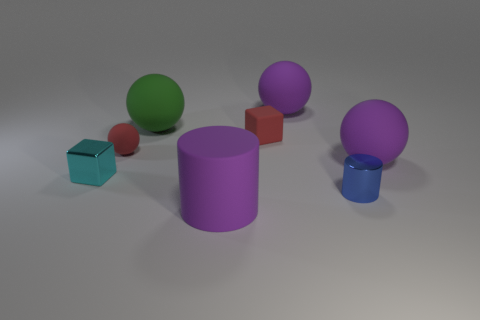There is a tiny block that is to the right of the rubber cylinder; is its color the same as the tiny rubber ball?
Your response must be concise. Yes. How many other things are there of the same color as the big cylinder?
Your answer should be very brief. 2. What number of objects are either objects or tiny red matte blocks?
Ensure brevity in your answer.  8. How many things are green balls or tiny red things that are left of the red matte block?
Your response must be concise. 2. Is the cyan cube made of the same material as the red sphere?
Provide a succinct answer. No. What number of other objects are there of the same material as the small red sphere?
Keep it short and to the point. 5. Are there more big things than red objects?
Ensure brevity in your answer.  Yes. Do the big purple matte object in front of the small cyan metal cube and the small blue object have the same shape?
Ensure brevity in your answer.  Yes. Are there fewer tiny things than brown balls?
Your response must be concise. No. There is a cylinder that is the same size as the green thing; what is its material?
Keep it short and to the point. Rubber. 